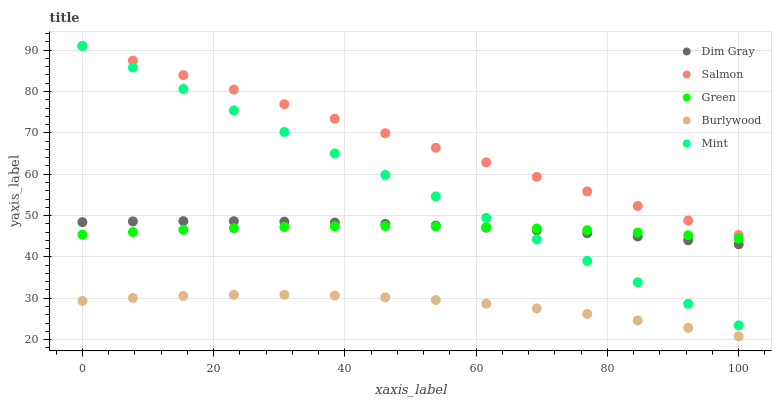Does Burlywood have the minimum area under the curve?
Answer yes or no. Yes. Does Salmon have the maximum area under the curve?
Answer yes or no. Yes. Does Green have the minimum area under the curve?
Answer yes or no. No. Does Green have the maximum area under the curve?
Answer yes or no. No. Is Salmon the smoothest?
Answer yes or no. Yes. Is Burlywood the roughest?
Answer yes or no. Yes. Is Green the smoothest?
Answer yes or no. No. Is Green the roughest?
Answer yes or no. No. Does Burlywood have the lowest value?
Answer yes or no. Yes. Does Green have the lowest value?
Answer yes or no. No. Does Mint have the highest value?
Answer yes or no. Yes. Does Green have the highest value?
Answer yes or no. No. Is Burlywood less than Green?
Answer yes or no. Yes. Is Dim Gray greater than Burlywood?
Answer yes or no. Yes. Does Mint intersect Dim Gray?
Answer yes or no. Yes. Is Mint less than Dim Gray?
Answer yes or no. No. Is Mint greater than Dim Gray?
Answer yes or no. No. Does Burlywood intersect Green?
Answer yes or no. No. 